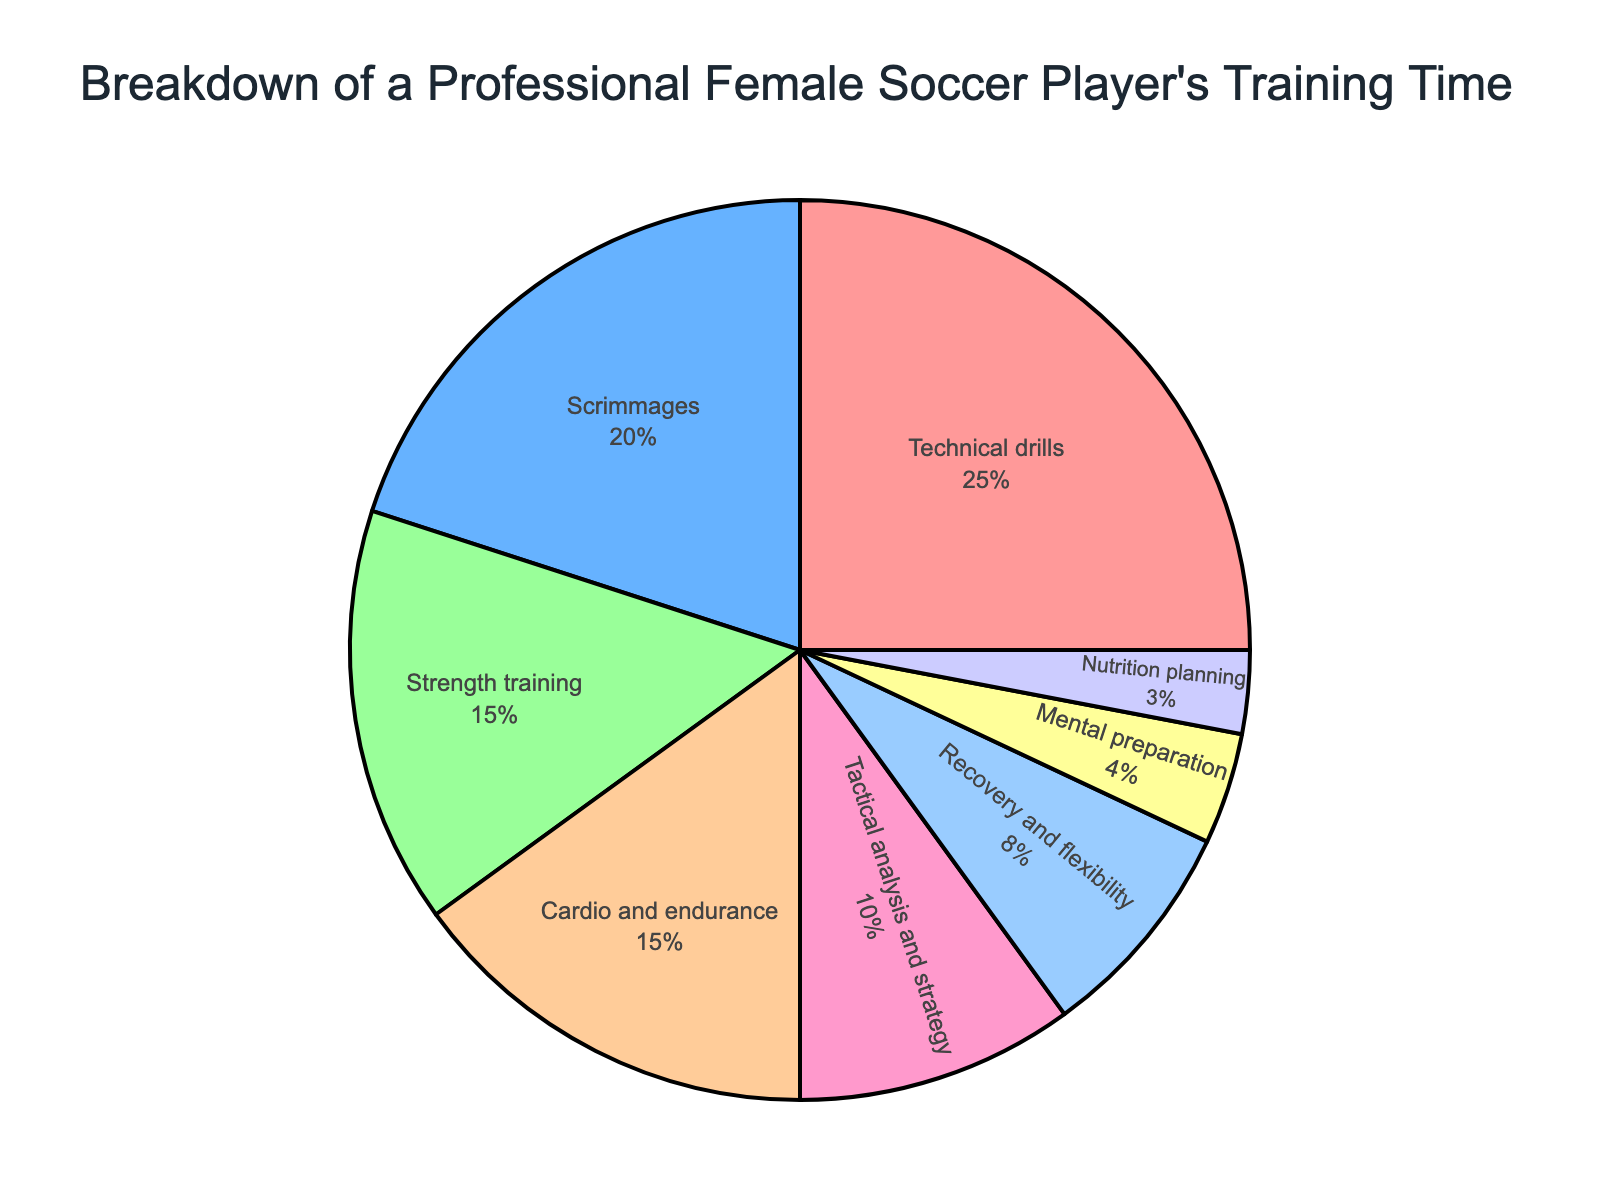What's the largest activity segment and what's its percentage? The largest activity segment can be identified by looking for the chunk that occupies the most space in the pie chart. The "Technical drills" segment is the largest, and according to the figure, it takes up 25%.
Answer: Technical drills, 25% What are the two smallest activity segments combined, and what is their total percentage? To find the two smallest segments, look for the smallest chunks in the pie chart. From the chart, "Nutrition planning" at 3% and "Mental preparation" at 4% are the smallest. Adding these together gives 3% + 4% = 7%.
Answer: Nutrition planning and Mental preparation, 7% Which activity takes up more time, Strength training or Cardio and endurance? Compare the sizes of the segments labeled "Strength training" and "Cardio and endurance." From the chart, both have the same percentage, 15%.
Answer: They are equal, both at 15% What percentage of the training time is dedicated to recovery and flexibility combined with nutrition planning? Find the percentages for "Recovery and flexibility" and "Nutrition planning" and add them. "Recovery and flexibility" is 8% and "Nutrition planning" is 3%, so together they make 8% + 3% = 11%.
Answer: 11% If the player decided to allocate 10% more time to Tactical analysis and strategy, what would the new percentage be for this activity? Starting with the current percentage for "Tactical analysis and strategy," which is 10%, adding 10% more time means doubling it. Thus, 10% + 10% = 20%.
Answer: 20% Out of Scrimmages and Tactical analysis and strategy, which activity takes up a smaller slice of the pie chart? Compare the labeled percentages of "Scrimmages" and "Tactical analysis and strategy." "Scrimmages" has 20%, while "Tactical analysis and strategy" has 10%. Thus, "Tactical analysis and strategy" takes up a smaller slice.
Answer: Tactical analysis and strategy How much more training time does Technical drills take compared to Mental preparation? Calculate the difference between the percentages for "Technical drills" and "Mental preparation." "Technical drills" is 25% and "Mental preparation" is 4%. The difference is 25% - 4% = 21%.
Answer: 21% What is the total percentage of training time allocated to Strength training, Cardio and endurance, and Tactical analysis and strategy? Add the percentages for "Strength training," "Cardio and endurance," and "Tactical analysis and strategy." They are 15%, 15%, and 10% respectively. So, 15% + 15% + 10% = 40%.
Answer: 40% How much less time is spent on Cardio and endurance compared to Technical drills? Find the percentage difference between "Technical drills" and "Cardio and endurance." "Technical drills" is 25% and "Cardio and endurance" is 15%. The difference is 25% - 15% = 10%.
Answer: 10% less 